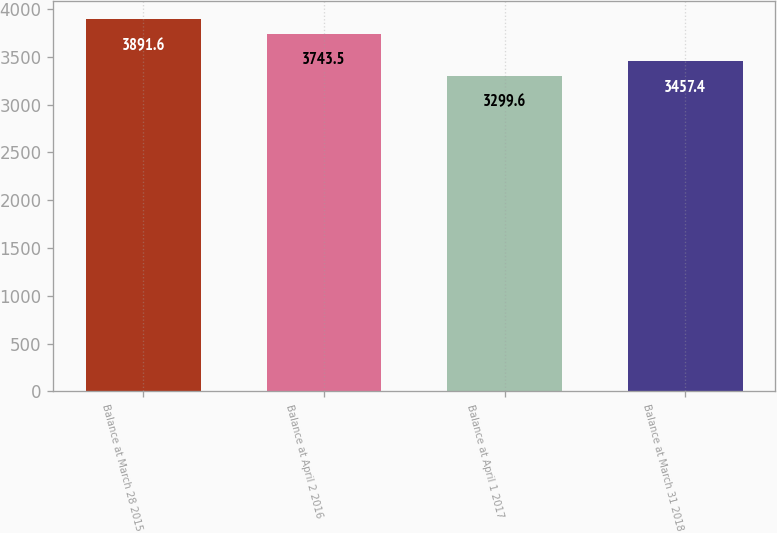<chart> <loc_0><loc_0><loc_500><loc_500><bar_chart><fcel>Balance at March 28 2015<fcel>Balance at April 2 2016<fcel>Balance at April 1 2017<fcel>Balance at March 31 2018<nl><fcel>3891.6<fcel>3743.5<fcel>3299.6<fcel>3457.4<nl></chart> 